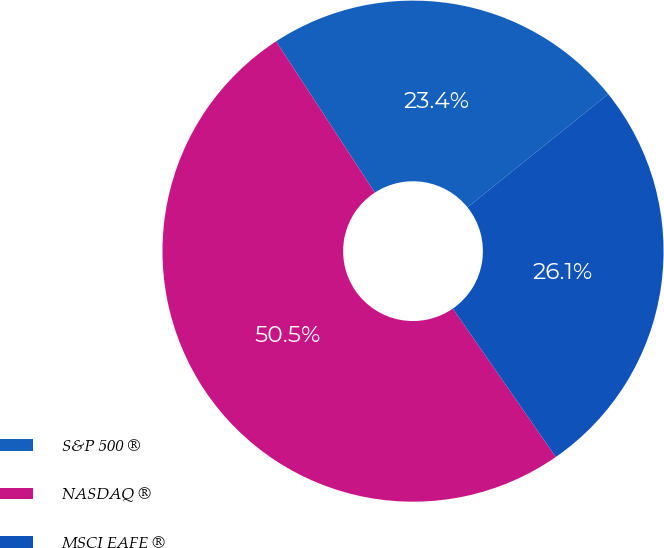Convert chart. <chart><loc_0><loc_0><loc_500><loc_500><pie_chart><fcel>S&P 500 ®<fcel>NASDAQ ®<fcel>MSCI EAFE ®<nl><fcel>23.42%<fcel>50.45%<fcel>26.13%<nl></chart> 